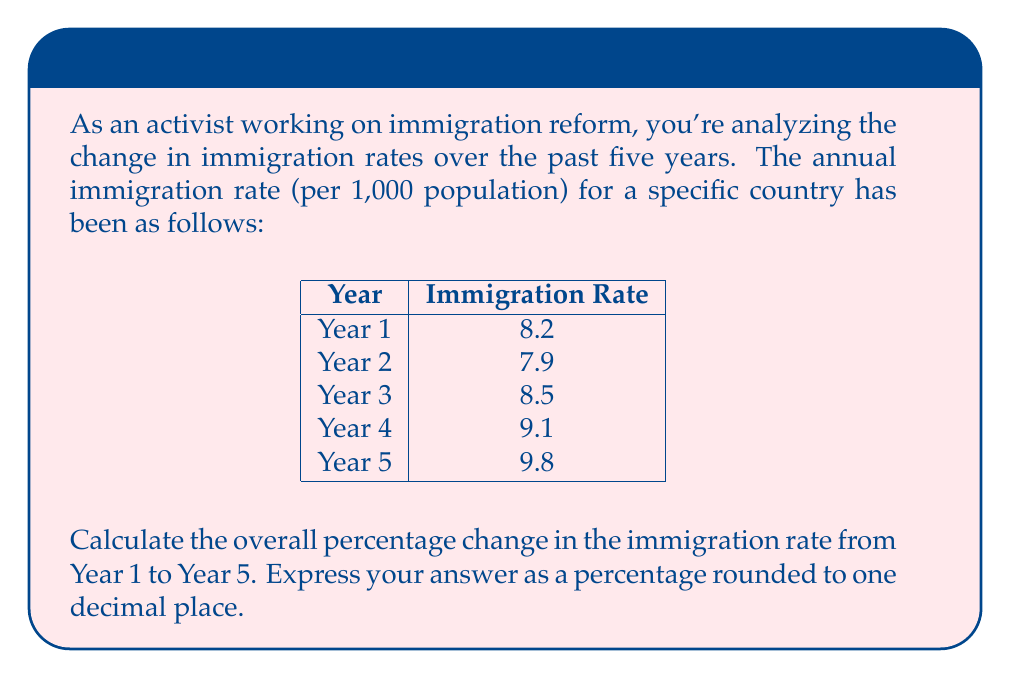Give your solution to this math problem. To calculate the overall percentage change in the immigration rate from Year 1 to Year 5, we'll use the following formula:

$$ \text{Percentage Change} = \frac{\text{Final Value} - \text{Initial Value}}{\text{Initial Value}} \times 100\% $$

Let's plug in our values:
- Initial Value (Year 1): 8.2
- Final Value (Year 5): 9.8

$$ \text{Percentage Change} = \frac{9.8 - 8.2}{8.2} \times 100\% $$

$$ = \frac{1.6}{8.2} \times 100\% $$

$$ = 0.1951219512 \times 100\% $$

$$ = 19.51219512\% $$

Rounding to one decimal place, we get 19.5%.

This means the immigration rate increased by 19.5% from Year 1 to Year 5.
Answer: 19.5% 